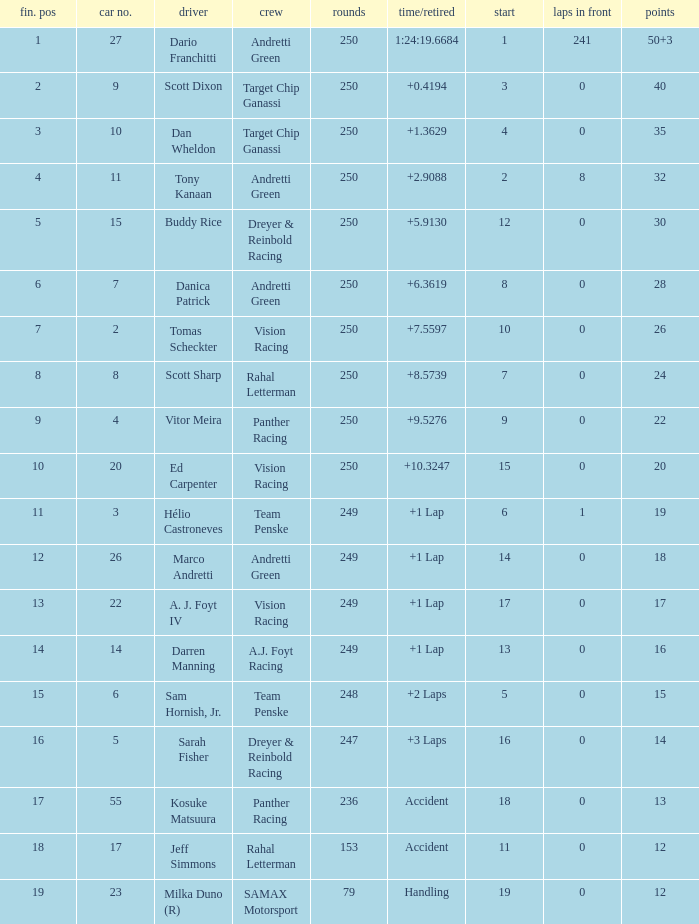Name the least grid for 17 points  17.0. 